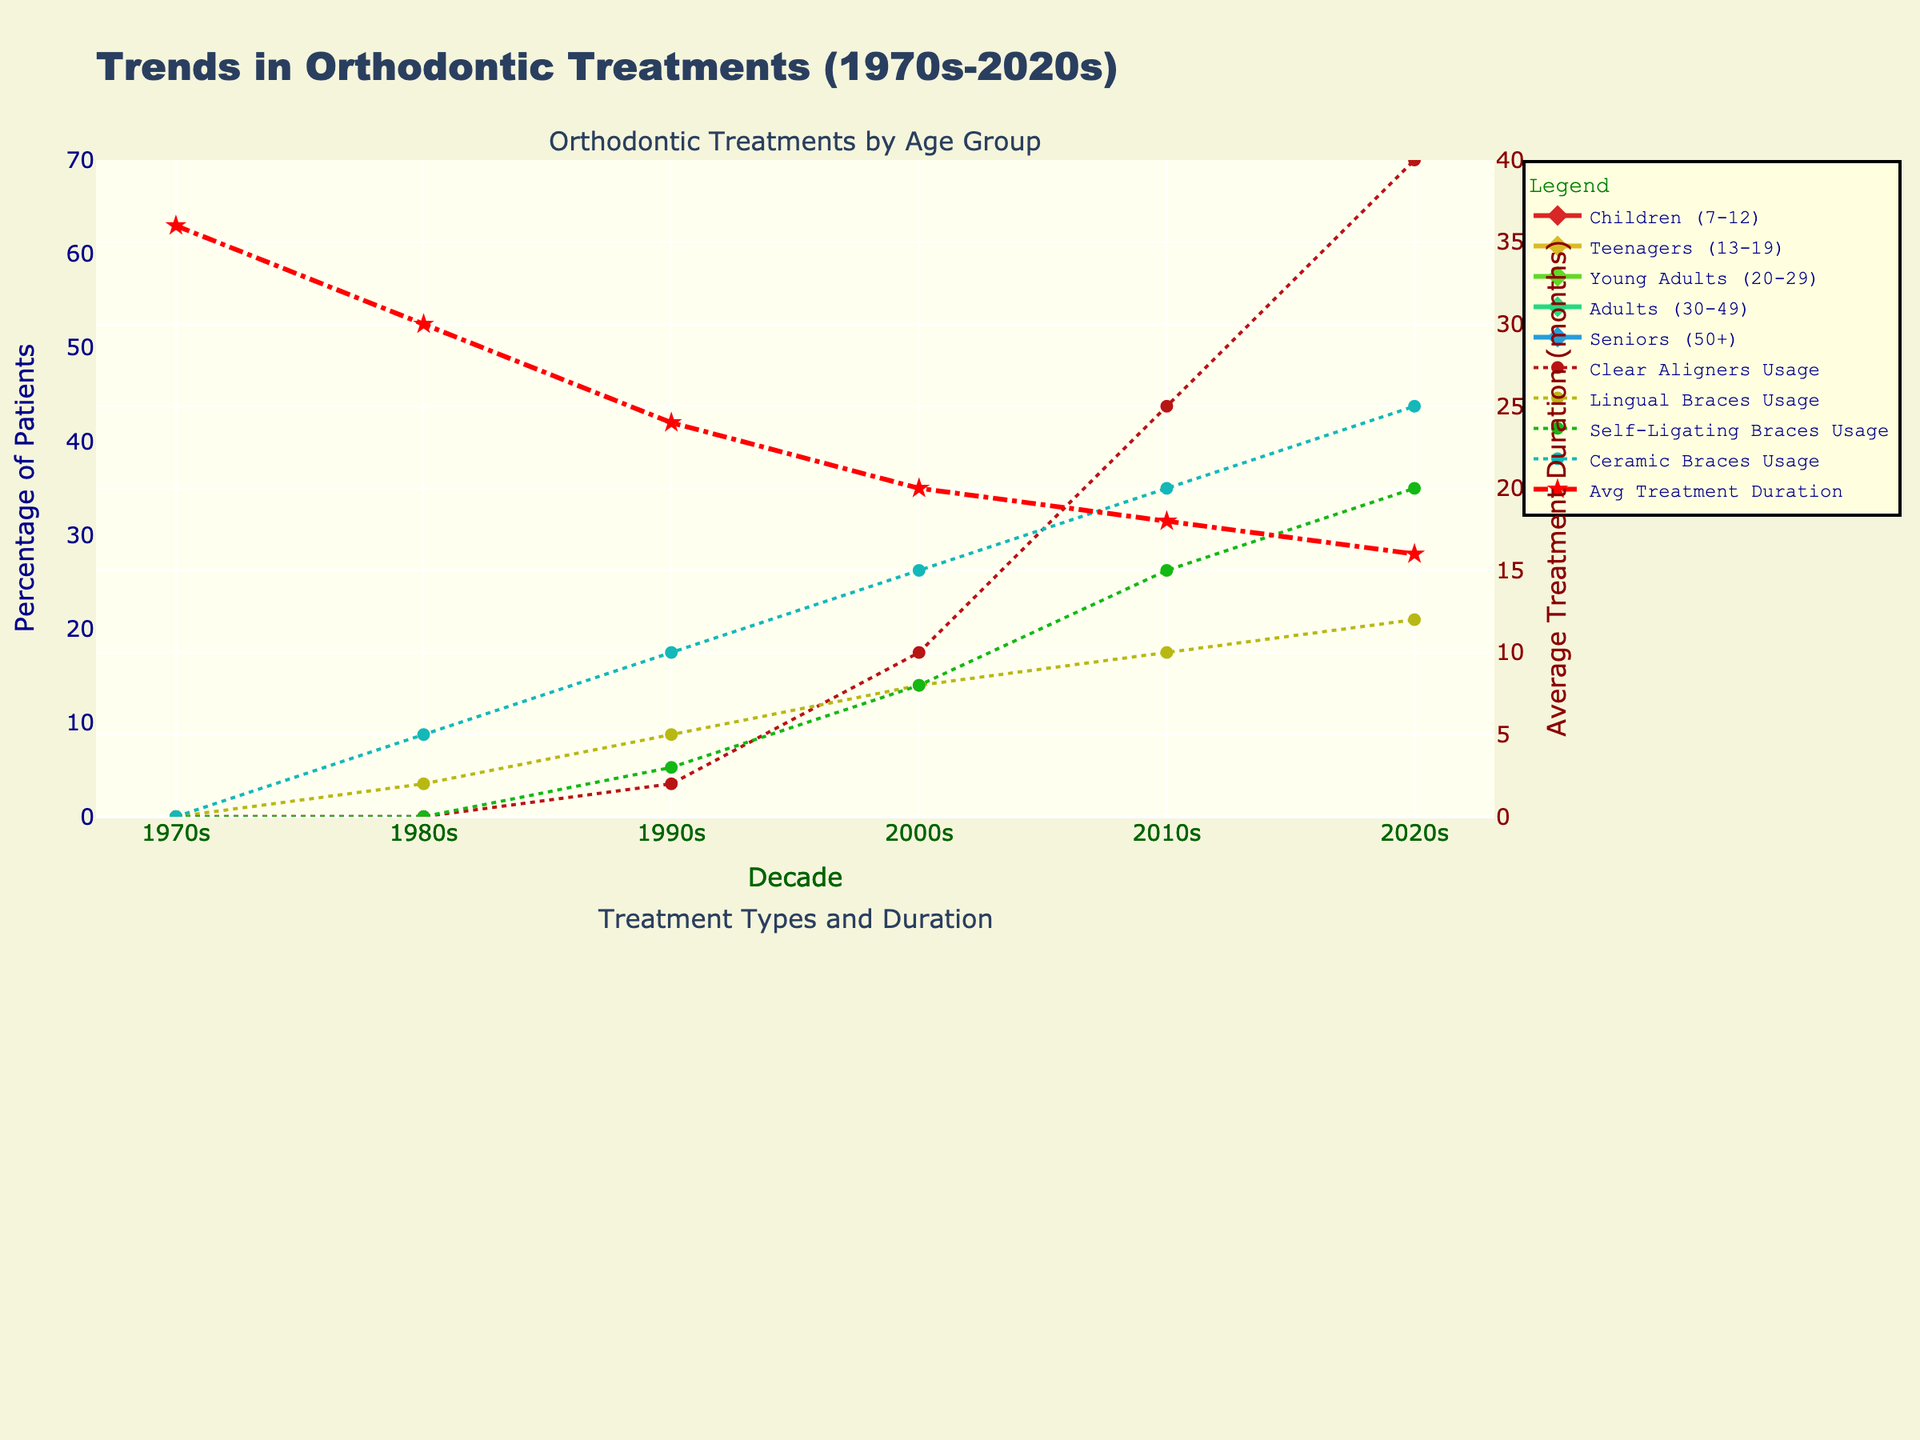Which age group shows the highest percentage increase in orthodontic treatments from the 1970s to the 2020s? First, find the percentage increase for each age group from the 1970s to the 2020s by subtracting the 1970s value from the 2020s value and then dividing by the 1970s value. The age group with the highest percentage increase is the one with the largest result.
Answer: Seniors (50+) Which age group had the highest percentage of orthodontic treatments in the 2010s? Look at the 2010s data for each age group and find the highest value. The corresponding age group is the answer.
Answer: Teenagers (13-19) By how many months has the average treatment duration decreased from the 1970s to the 2020s? Subtract the 2020s value for average treatment duration from the 1970s value: 36 - 16 = 20.
Answer: 20 Compare the usage of Clear Aligners and Self-Ligating Braces in the 2020s. Which one has higher usage and by how much? Look at the 2020s data for Clear Aligners and Self-Ligating Braces, find the difference: 40 - 20 = 20. Clear Aligners have higher usage by 20 percentage points.
Answer: Clear Aligners, 20 Which treatment type had no usage until the 1990s? Check the data for each treatment type and find which ones have 0s in the 1970s and 1980s and a positive value starting in the 1990s.
Answer: Clear Aligners, Self-Ligating Braces How many lines on the top subplot intersect at the point representing the 2000s? Look at the top subplot and count how many lines cross or meet at the vertical line marking the year 2000s.
Answer: 5 Which age group shows the steepest incline in orthodontic treatment from the 1980s to the 1990s? Calculate the slope for each age group between the 1980s and 1990s by finding the difference in these decades. The age group with the largest slope shows the steepest incline.
Answer: Children (7-12) What is the difference in orthodontic treatment percentages between Young Adults (20-29) and Adults (30-49) in the 1990s? Subtract the percentage for Adults (30-49) from Young Adults (20-29) in the 1990s: 20 - 12 = 8.
Answer: 8 Among the listed treatment types, which one shows a continuous increase from the 1970s to the 2020s without any drop? Examine the trend lines for each treatment type in the second subplot and identify the one whose values keep increasing.
Answer: Ceramic Braces In which decade did the average treatment duration first drop below 24 months? Look at the trends for average treatment duration and find the first decade where the value drops below 24.
Answer: 1990s 